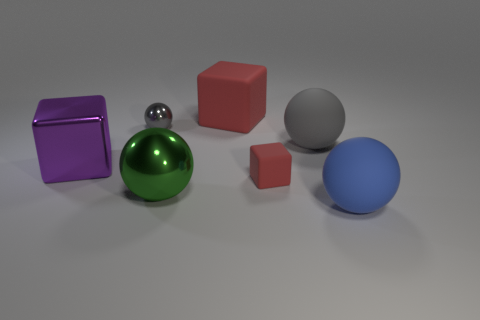Does the large green shiny thing have the same shape as the big rubber thing that is in front of the purple metallic cube?
Make the answer very short. Yes. What is the large gray ball made of?
Offer a terse response. Rubber. There is a gray metal object that is the same shape as the blue object; what size is it?
Ensure brevity in your answer.  Small. How many other things are there of the same material as the tiny red object?
Your response must be concise. 3. Do the small block and the large sphere that is on the left side of the big gray sphere have the same material?
Offer a very short reply. No. Is the number of big green shiny spheres that are behind the tiny red cube less than the number of small shiny objects behind the large blue sphere?
Provide a succinct answer. Yes. What is the color of the big block in front of the big gray rubber thing?
Offer a very short reply. Purple. What number of other objects are the same color as the large shiny ball?
Offer a very short reply. 0. Is the size of the gray object to the right of the green metallic sphere the same as the big red thing?
Keep it short and to the point. Yes. How many red rubber objects are behind the large metallic sphere?
Ensure brevity in your answer.  2. 